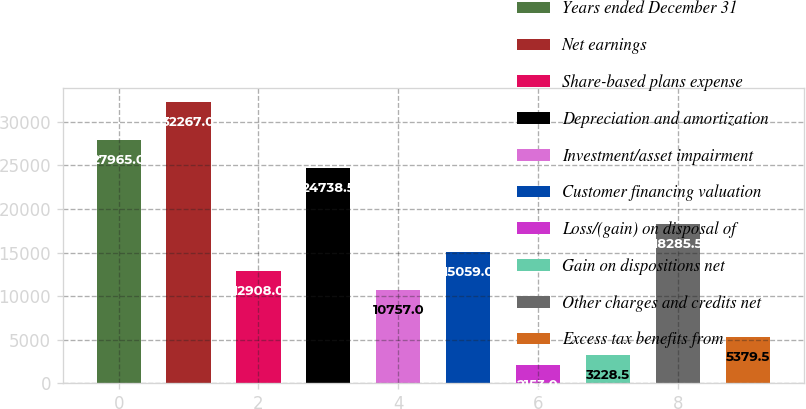<chart> <loc_0><loc_0><loc_500><loc_500><bar_chart><fcel>Years ended December 31<fcel>Net earnings<fcel>Share-based plans expense<fcel>Depreciation and amortization<fcel>Investment/asset impairment<fcel>Customer financing valuation<fcel>Loss/(gain) on disposal of<fcel>Gain on dispositions net<fcel>Other charges and credits net<fcel>Excess tax benefits from<nl><fcel>27965<fcel>32267<fcel>12908<fcel>24738.5<fcel>10757<fcel>15059<fcel>2153<fcel>3228.5<fcel>18285.5<fcel>5379.5<nl></chart> 